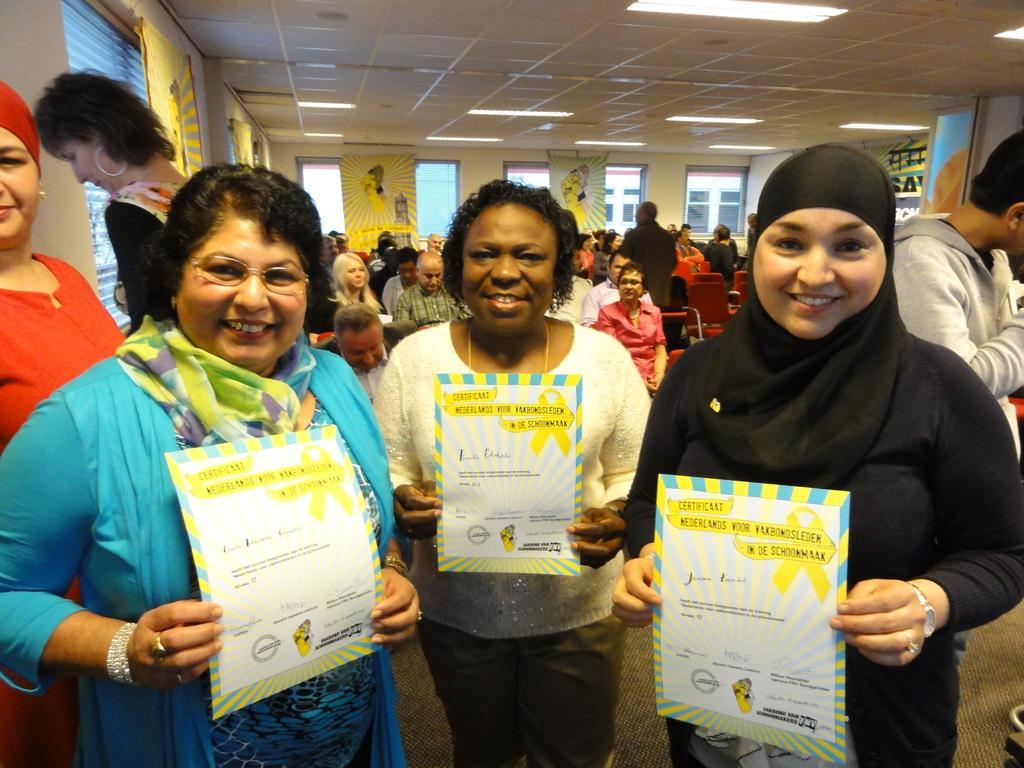Please provide a concise description of this image. In this image we can see persons standing on the floor and holding papers in their hands. In the background there are people sitting on the chairs and some are standing on the floor, advertisements to the walls, electric lights to the roof and buildings through the windows. 